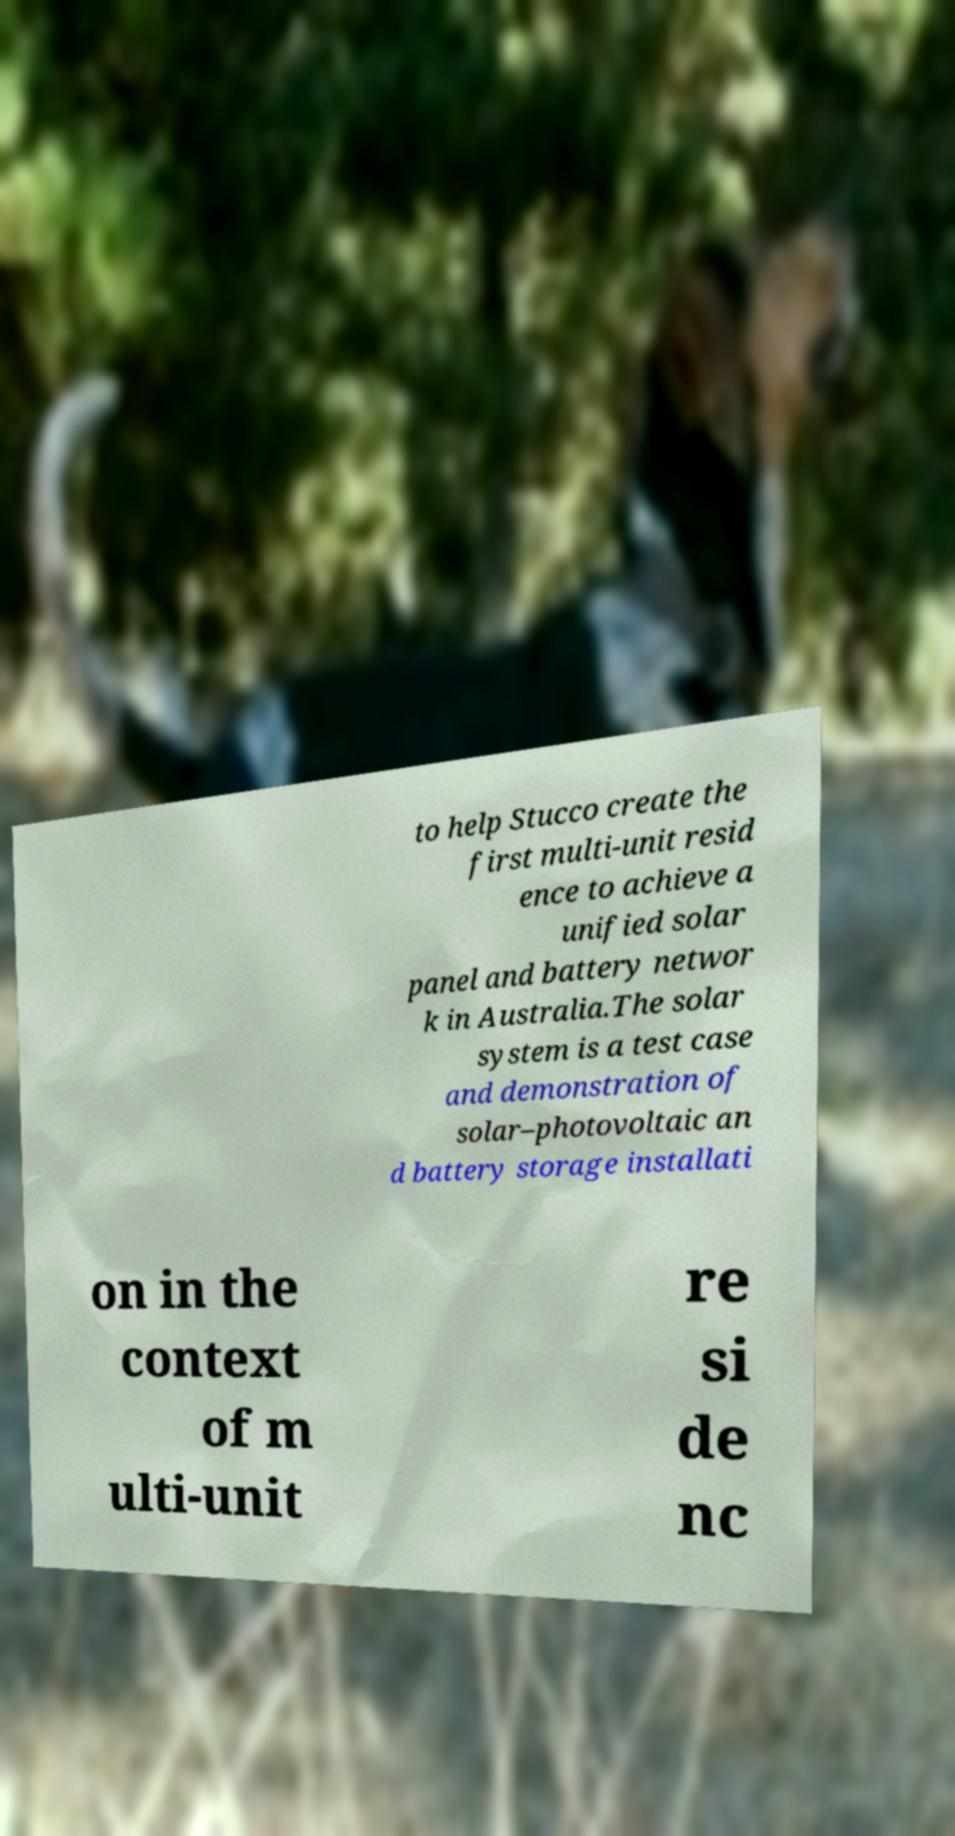There's text embedded in this image that I need extracted. Can you transcribe it verbatim? to help Stucco create the first multi-unit resid ence to achieve a unified solar panel and battery networ k in Australia.The solar system is a test case and demonstration of solar–photovoltaic an d battery storage installati on in the context of m ulti-unit re si de nc 